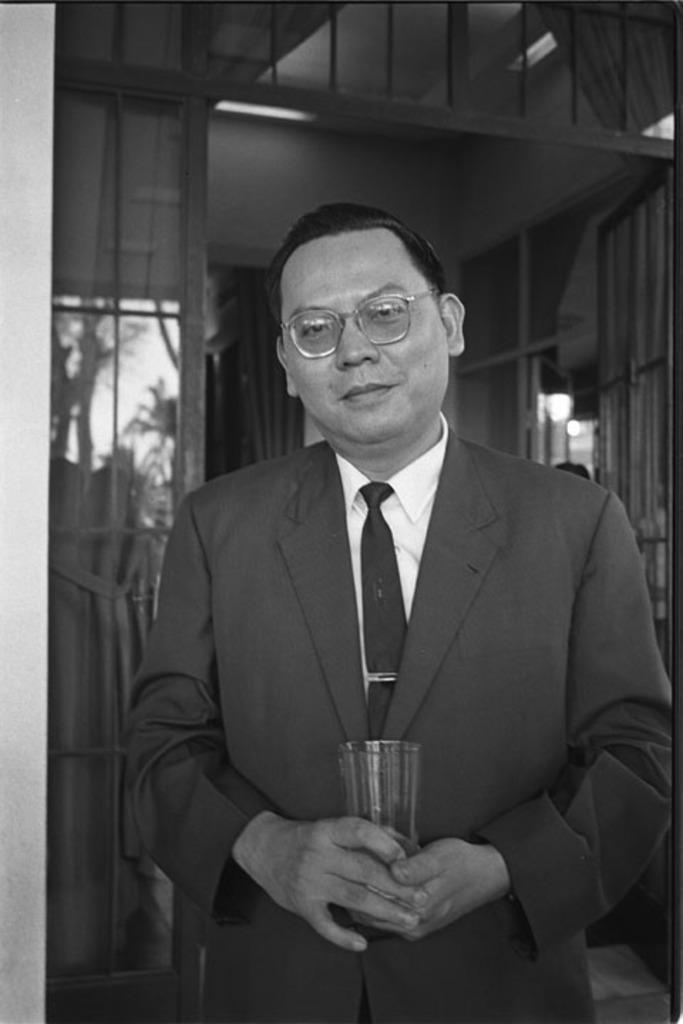What is the main subject of the image? There is a man in the middle of the image. What is the man wearing? The man is wearing a suit, a shirt, and a tie. What is the man holding in the image? The man is holding a glass. What can be seen in the background of the image? There is light, windows, trees, and the sky visible in the background of the image. How many rabbits can be seen in the image? There are no rabbits present in the image. What type of scent is coming from the man's tie in the image? There is no mention of a scent in the image, and the man's tie does not have a scent. 